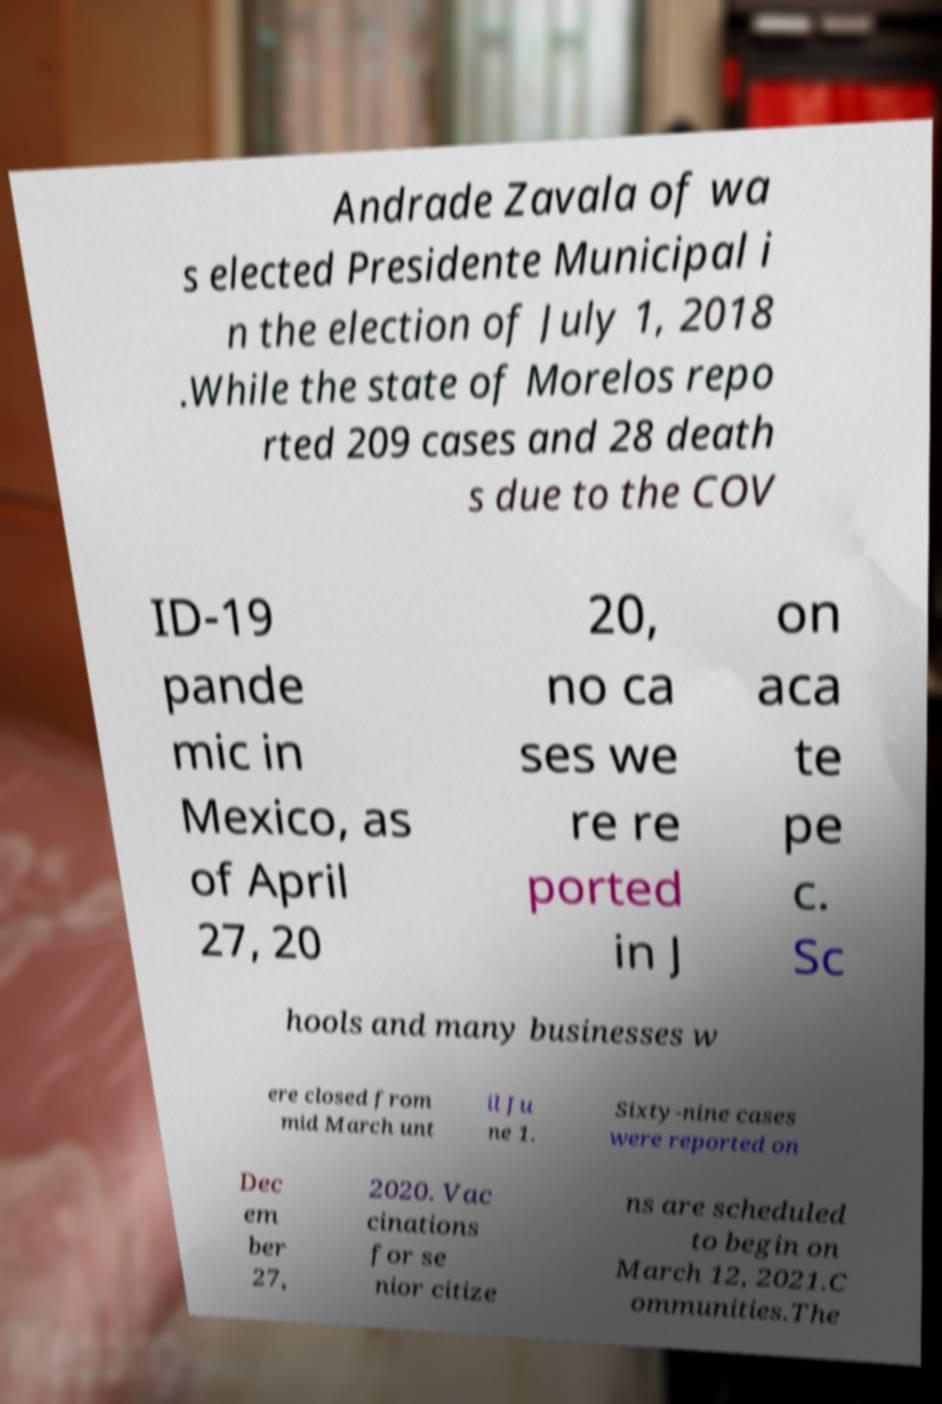What messages or text are displayed in this image? I need them in a readable, typed format. Andrade Zavala of wa s elected Presidente Municipal i n the election of July 1, 2018 .While the state of Morelos repo rted 209 cases and 28 death s due to the COV ID-19 pande mic in Mexico, as of April 27, 20 20, no ca ses we re re ported in J on aca te pe c. Sc hools and many businesses w ere closed from mid March unt il Ju ne 1. Sixty-nine cases were reported on Dec em ber 27, 2020. Vac cinations for se nior citize ns are scheduled to begin on March 12, 2021.C ommunities.The 